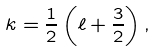<formula> <loc_0><loc_0><loc_500><loc_500>k = \frac { 1 } { 2 } \left ( \ell + \frac { 3 } { 2 } \right ) ,</formula> 